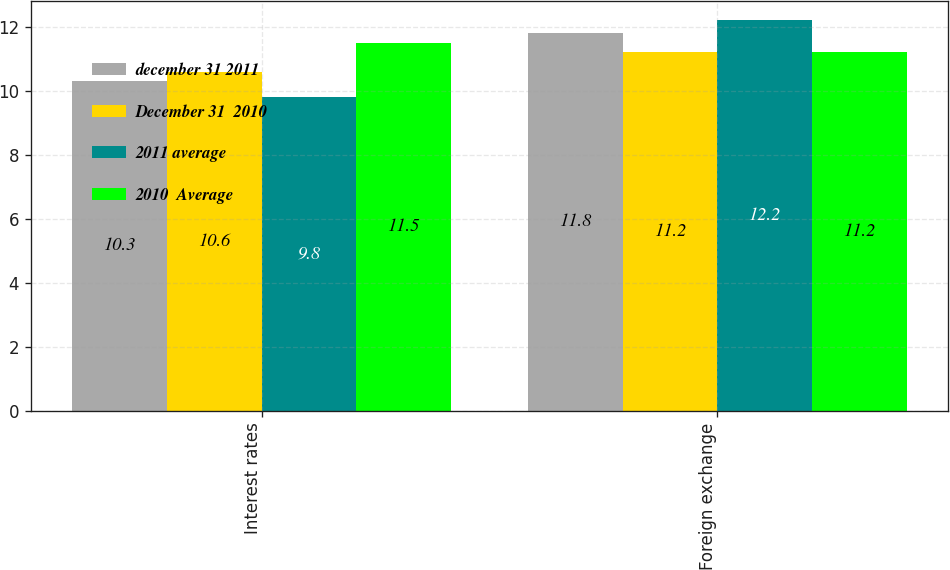<chart> <loc_0><loc_0><loc_500><loc_500><stacked_bar_chart><ecel><fcel>Interest rates<fcel>Foreign exchange<nl><fcel>december 31 2011<fcel>10.3<fcel>11.8<nl><fcel>December 31  2010<fcel>10.6<fcel>11.2<nl><fcel>2011 average<fcel>9.8<fcel>12.2<nl><fcel>2010  Average<fcel>11.5<fcel>11.2<nl></chart> 